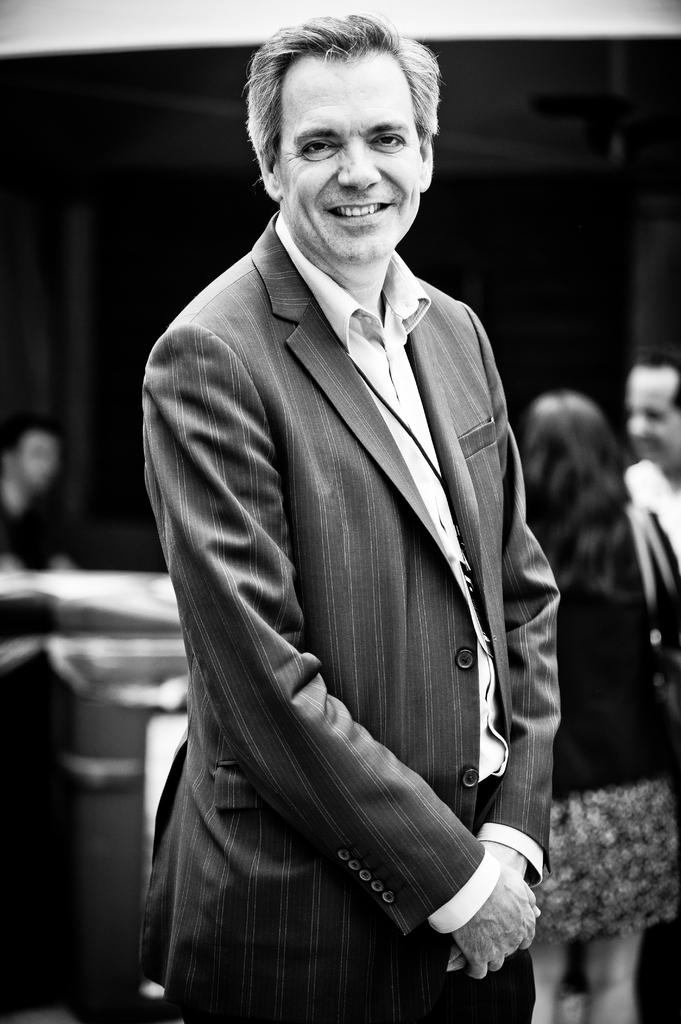What is the main subject of the image? There is a person standing in the image. Can you describe the people behind the person standing? There are a few people visible behind the person standing. What type of work is the cannon doing in the image? There is no cannon present in the image, so it cannot be performing any work. 